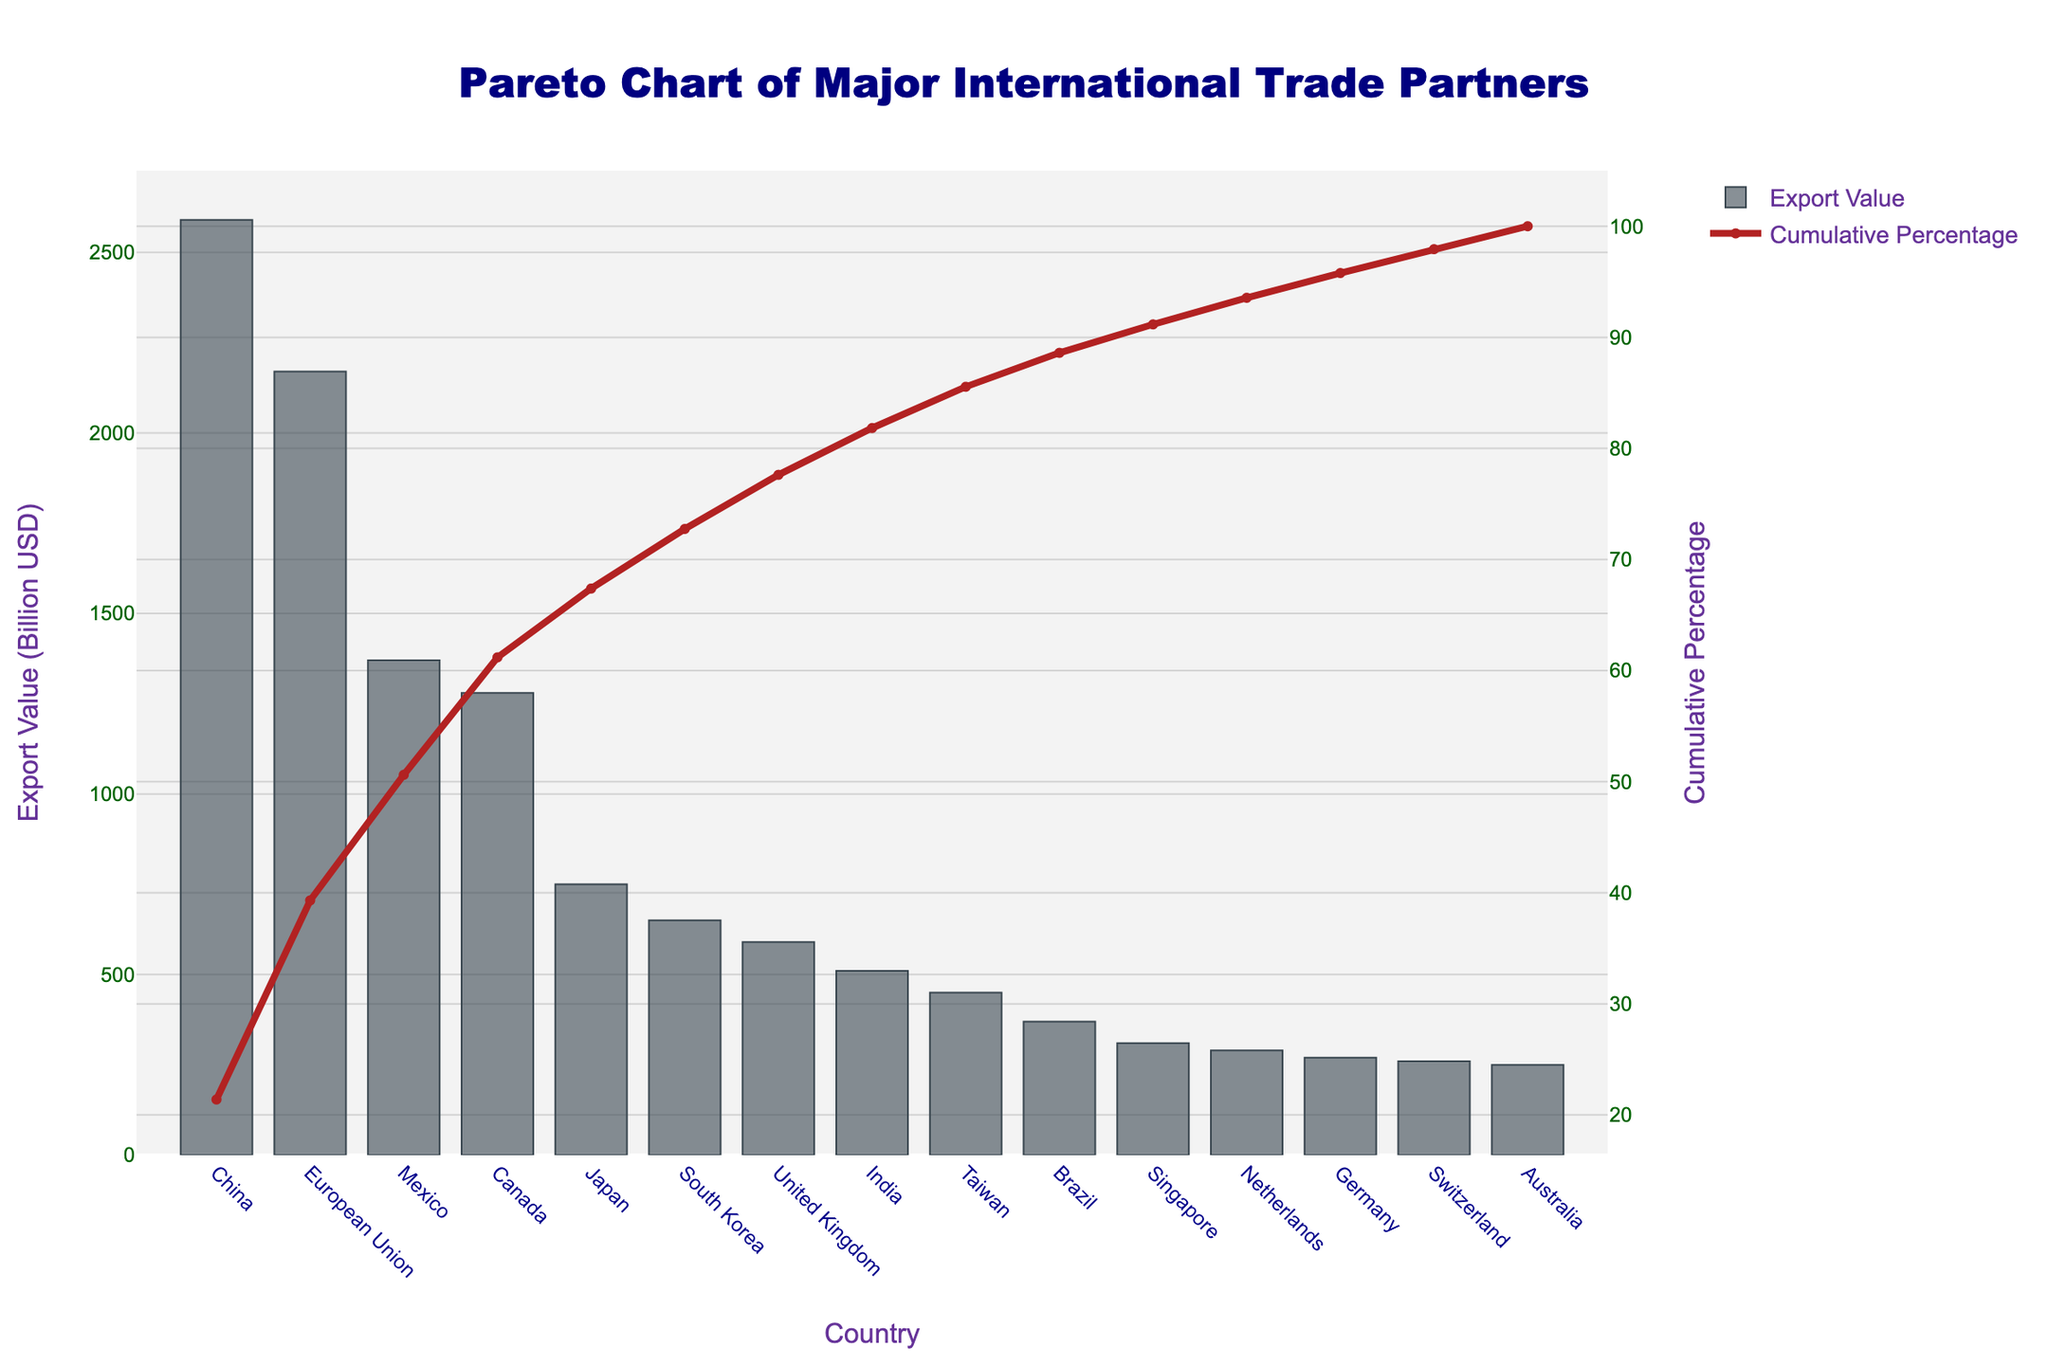what is the title of the chart? The title is usually displayed at the top of the chart. The large font size and central placement make it recognizable as the title.
Answer: Pareto Chart of Major International Trade Partners How many countries are displayed on the X-axis? By counting the number of tick labels along the X-axis, we see there are 15 different countries listed.
Answer: 15 Which country has the highest export value? We identify the country with the tallest bar on the chart, which is on the far left.
Answer: China What is the cumulative percentage value for South Korea? Follow the line corresponding to South Korea on the X-axis and check the value on the secondary Y-axis.
Answer: Approximately 76% What is the difference in export value between Mexico and Canada? Subtract the export value of Canada from that of Mexico (1370 - 1280 billion USD).
Answer: 90 billion USD How many countries account for approximately 50% of the total export value? Follow the cumulative percentage line up to 50% on the secondary Y-axis and count the number of countries up to this point.
Answer: 3 countries Which country lies directly at the 80% cumulative percentage mark? Follow the cumulative percentage line to where it meets 80% on the secondary Y-axis and check the corresponding country on the X-axis.
Answer: United Kingdom What is the export value of India? Locate India on the X-axis and observe the height of the corresponding bar, then refer to the primary Y-axis for the value.
Answer: 510 billion USD Compare the export values of Japan and Taiwan. Which country has a higher export value, and by how much? Japan has a higher export value. Subtract Taiwan's export value from Japan's (750 - 450 billion USD).
Answer: Japan has a higher export value by 300 billion USD What percentage of the total export value do the top five countries account for? Sum the export values of the top five countries (China, European Union, Mexico, Canada, Japan) and divide by the total export value, then multiply by 100.
Answer: 85% 